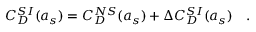<formula> <loc_0><loc_0><loc_500><loc_500>C _ { D } ^ { S I } ( a _ { s } ) = C _ { D } ^ { N S } ( a _ { s } ) + \Delta C _ { D } ^ { S I } ( a _ { s } ) .</formula> 